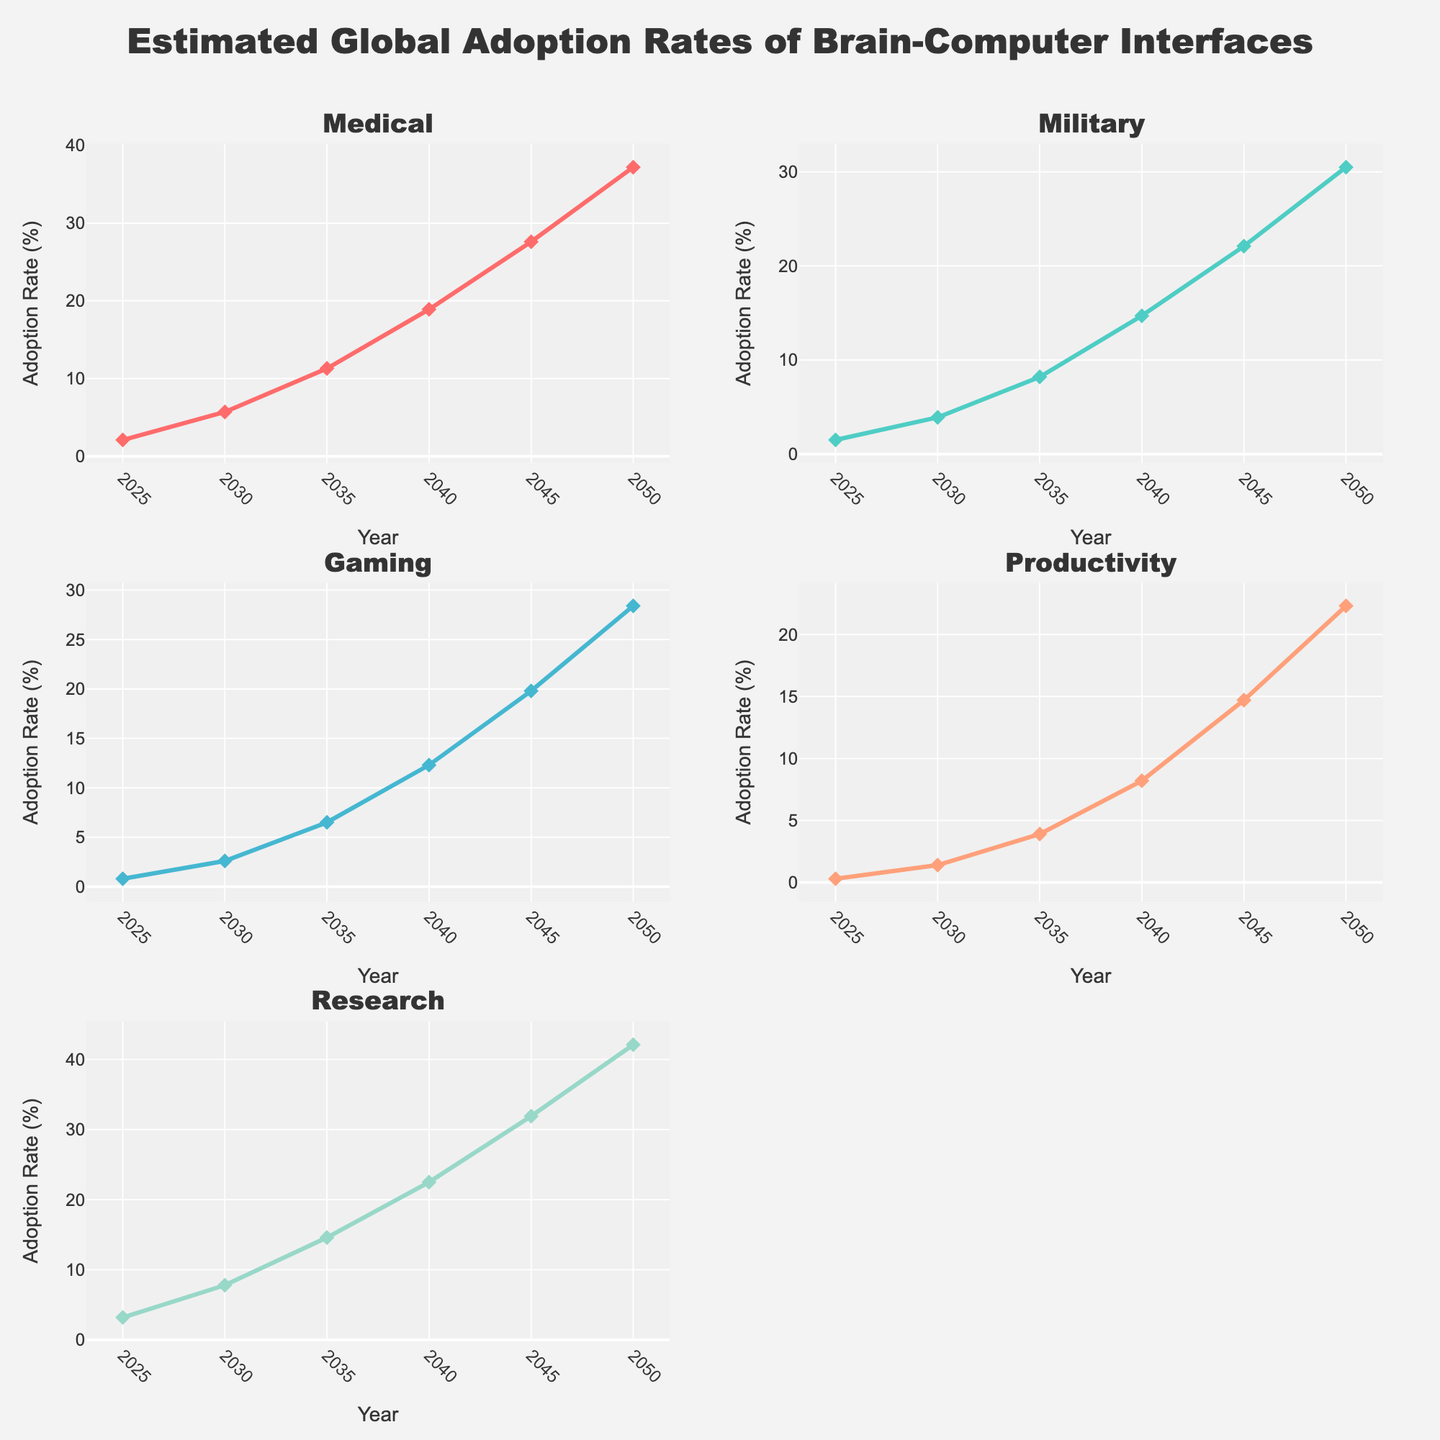What is the title of the overall figure? The title is usually displayed prominently at the top of the figure. It often gives a clear summary of what the entire figure represents or analyses.
Answer: Fashion Trends in Men's and Women's Business Attire (1960-1970) How many subplots are there within the figure? The subplots are counted by checking the individual smaller plots within the entire figure. Each subplot corresponds to a different aspect of the fashion trends data.
Answer: 6 What color is used to represent 'Men's Ties'? Look at the line and markers associated with 'Men's Ties' and identify its color. Each category is colored differently for distinction.
Answer: Green What was the typical style for men’s hats in 1966? To find this, look at the data point for 'Men's Hats' in the year 1966 on its respective subplot.
Answer: Porkpie Which year saw the introduction of the "Peasant" style for women's blouses? Check the subplot for 'Women's Blouses'. The type "Peasant" appears at the marker corresponding to the particular year on the x-axis.
Answer: 1970 Did women’s heels show an increasing, decreasing, or no specific pattern in terms of variety from 1960 to 1970? Track the types of 'Women's Heels' across the years. Compare whether the types show progression (increasing or more variety), regression (decreasing or less variety), or randomness (no specific pattern).
Answer: Increasing What men's fashion item showed the most variety changes between 1960 and 1970? Analyze each subplot for 'Men's Suits', 'Men's Ties', and 'Men's Hats', and identify which one has the most distinct changes in style over the years.
Answer: Men's Hats Was there more evolution in men’s or women’s business attire during this period? Compare the subplots for men’s items ('Men's Suits', 'Men's Ties', 'Men's Hats') versus women’s items ('Women's Skirts', 'Women's Blouses', 'Women's Heels') and see which has more variation in styles.
Answer: Women's What is the trend in the length of women's skirts from 1960 to 1970? Look at the 'Women's Skirts' subplot and track the lengths (knee-length, pencil, A-line, mini, midi, maxi) over the years to identify the trend.
Answer: Increasing Which two styles for 'Women's Heels' appear in consecutive years? Check the subplot for 'Women's Heels' and identify styles that follow one another in consecutive years.
Answer: Kitten to Stiletto (1960 to 1962) 